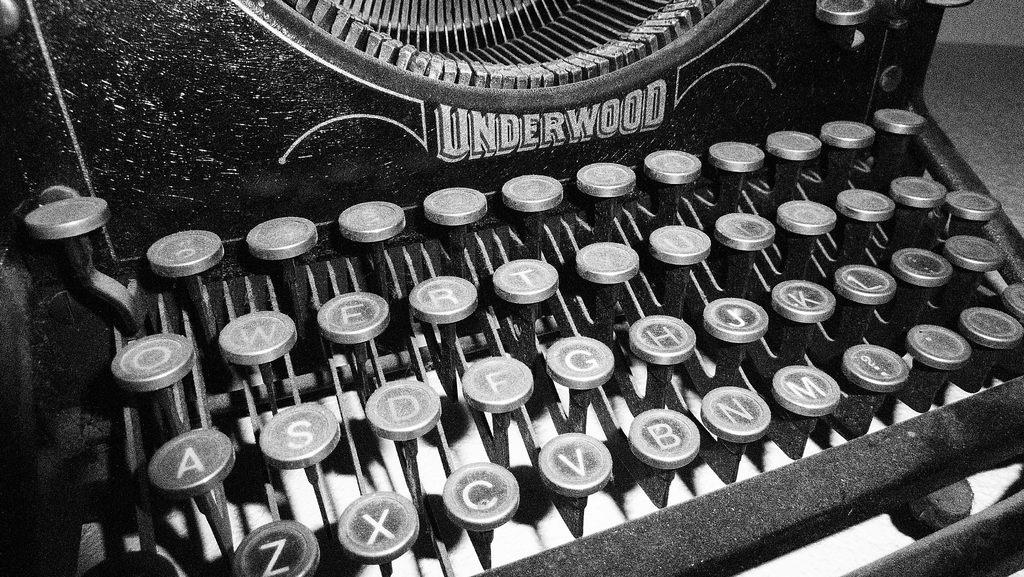<image>
Describe the image concisely. a black and white photo of an underwood typewriter 